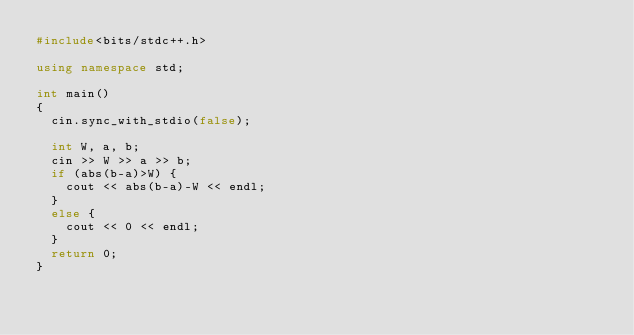<code> <loc_0><loc_0><loc_500><loc_500><_C++_>#include<bits/stdc++.h>

using namespace std;

int main()
{
	cin.sync_with_stdio(false);

	int W, a, b;
	cin >> W >> a >> b;
	if (abs(b-a)>W) {
		cout << abs(b-a)-W << endl;
	}
	else {
		cout << 0 << endl;
	}
	return 0;
}</code> 